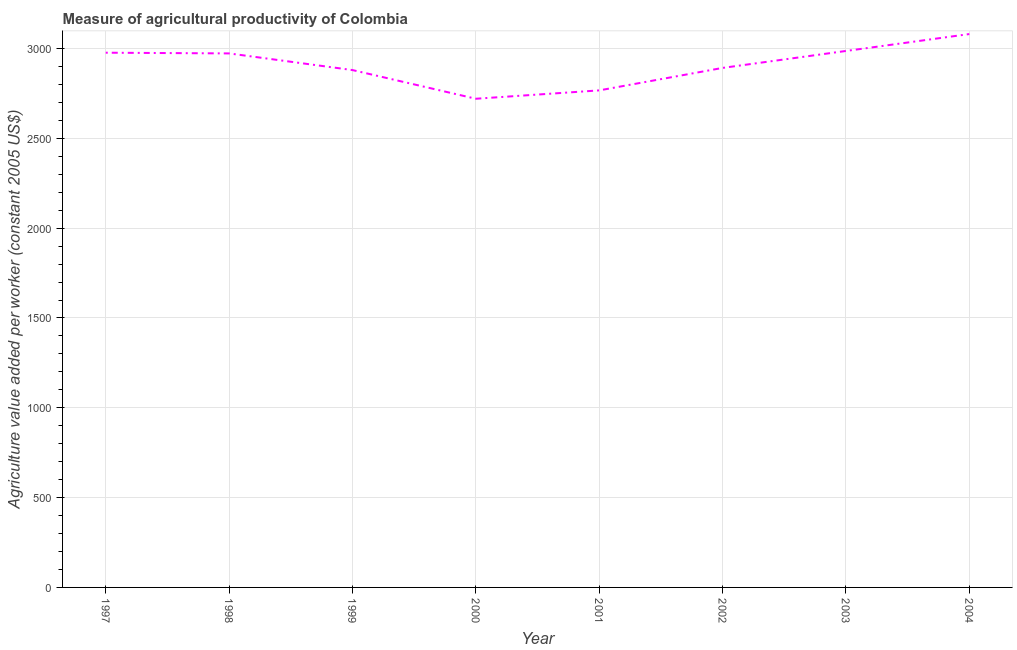What is the agriculture value added per worker in 2002?
Make the answer very short. 2892.19. Across all years, what is the maximum agriculture value added per worker?
Provide a short and direct response. 3080.64. Across all years, what is the minimum agriculture value added per worker?
Your response must be concise. 2720.53. What is the sum of the agriculture value added per worker?
Your answer should be very brief. 2.33e+04. What is the difference between the agriculture value added per worker in 1999 and 2004?
Your answer should be very brief. -200.45. What is the average agriculture value added per worker per year?
Make the answer very short. 2909.61. What is the median agriculture value added per worker?
Ensure brevity in your answer.  2932.52. In how many years, is the agriculture value added per worker greater than 600 US$?
Offer a terse response. 8. What is the ratio of the agriculture value added per worker in 2000 to that in 2004?
Provide a succinct answer. 0.88. Is the agriculture value added per worker in 2002 less than that in 2004?
Keep it short and to the point. Yes. Is the difference between the agriculture value added per worker in 2002 and 2004 greater than the difference between any two years?
Your answer should be very brief. No. What is the difference between the highest and the second highest agriculture value added per worker?
Offer a terse response. 94.08. Is the sum of the agriculture value added per worker in 1999 and 2003 greater than the maximum agriculture value added per worker across all years?
Offer a very short reply. Yes. What is the difference between the highest and the lowest agriculture value added per worker?
Provide a succinct answer. 360.11. In how many years, is the agriculture value added per worker greater than the average agriculture value added per worker taken over all years?
Provide a succinct answer. 4. Does the agriculture value added per worker monotonically increase over the years?
Offer a terse response. No. How many lines are there?
Make the answer very short. 1. How many years are there in the graph?
Make the answer very short. 8. Are the values on the major ticks of Y-axis written in scientific E-notation?
Provide a short and direct response. No. Does the graph contain any zero values?
Ensure brevity in your answer.  No. Does the graph contain grids?
Keep it short and to the point. Yes. What is the title of the graph?
Make the answer very short. Measure of agricultural productivity of Colombia. What is the label or title of the Y-axis?
Offer a terse response. Agriculture value added per worker (constant 2005 US$). What is the Agriculture value added per worker (constant 2005 US$) of 1997?
Provide a succinct answer. 2976.84. What is the Agriculture value added per worker (constant 2005 US$) in 1998?
Your answer should be very brief. 2972.85. What is the Agriculture value added per worker (constant 2005 US$) of 1999?
Offer a very short reply. 2880.19. What is the Agriculture value added per worker (constant 2005 US$) of 2000?
Provide a succinct answer. 2720.53. What is the Agriculture value added per worker (constant 2005 US$) in 2001?
Make the answer very short. 2767.07. What is the Agriculture value added per worker (constant 2005 US$) in 2002?
Offer a very short reply. 2892.19. What is the Agriculture value added per worker (constant 2005 US$) in 2003?
Offer a terse response. 2986.56. What is the Agriculture value added per worker (constant 2005 US$) in 2004?
Your response must be concise. 3080.64. What is the difference between the Agriculture value added per worker (constant 2005 US$) in 1997 and 1998?
Give a very brief answer. 3.99. What is the difference between the Agriculture value added per worker (constant 2005 US$) in 1997 and 1999?
Your answer should be very brief. 96.66. What is the difference between the Agriculture value added per worker (constant 2005 US$) in 1997 and 2000?
Keep it short and to the point. 256.32. What is the difference between the Agriculture value added per worker (constant 2005 US$) in 1997 and 2001?
Ensure brevity in your answer.  209.77. What is the difference between the Agriculture value added per worker (constant 2005 US$) in 1997 and 2002?
Make the answer very short. 84.65. What is the difference between the Agriculture value added per worker (constant 2005 US$) in 1997 and 2003?
Your answer should be very brief. -9.71. What is the difference between the Agriculture value added per worker (constant 2005 US$) in 1997 and 2004?
Offer a very short reply. -103.79. What is the difference between the Agriculture value added per worker (constant 2005 US$) in 1998 and 1999?
Offer a terse response. 92.67. What is the difference between the Agriculture value added per worker (constant 2005 US$) in 1998 and 2000?
Provide a short and direct response. 252.32. What is the difference between the Agriculture value added per worker (constant 2005 US$) in 1998 and 2001?
Keep it short and to the point. 205.78. What is the difference between the Agriculture value added per worker (constant 2005 US$) in 1998 and 2002?
Give a very brief answer. 80.66. What is the difference between the Agriculture value added per worker (constant 2005 US$) in 1998 and 2003?
Offer a very short reply. -13.71. What is the difference between the Agriculture value added per worker (constant 2005 US$) in 1998 and 2004?
Your answer should be very brief. -107.79. What is the difference between the Agriculture value added per worker (constant 2005 US$) in 1999 and 2000?
Your answer should be very brief. 159.66. What is the difference between the Agriculture value added per worker (constant 2005 US$) in 1999 and 2001?
Your answer should be very brief. 113.11. What is the difference between the Agriculture value added per worker (constant 2005 US$) in 1999 and 2002?
Your answer should be compact. -12. What is the difference between the Agriculture value added per worker (constant 2005 US$) in 1999 and 2003?
Offer a terse response. -106.37. What is the difference between the Agriculture value added per worker (constant 2005 US$) in 1999 and 2004?
Keep it short and to the point. -200.45. What is the difference between the Agriculture value added per worker (constant 2005 US$) in 2000 and 2001?
Offer a very short reply. -46.55. What is the difference between the Agriculture value added per worker (constant 2005 US$) in 2000 and 2002?
Keep it short and to the point. -171.66. What is the difference between the Agriculture value added per worker (constant 2005 US$) in 2000 and 2003?
Your response must be concise. -266.03. What is the difference between the Agriculture value added per worker (constant 2005 US$) in 2000 and 2004?
Your answer should be very brief. -360.11. What is the difference between the Agriculture value added per worker (constant 2005 US$) in 2001 and 2002?
Make the answer very short. -125.12. What is the difference between the Agriculture value added per worker (constant 2005 US$) in 2001 and 2003?
Your response must be concise. -219.48. What is the difference between the Agriculture value added per worker (constant 2005 US$) in 2001 and 2004?
Provide a short and direct response. -313.56. What is the difference between the Agriculture value added per worker (constant 2005 US$) in 2002 and 2003?
Give a very brief answer. -94.37. What is the difference between the Agriculture value added per worker (constant 2005 US$) in 2002 and 2004?
Provide a succinct answer. -188.45. What is the difference between the Agriculture value added per worker (constant 2005 US$) in 2003 and 2004?
Make the answer very short. -94.08. What is the ratio of the Agriculture value added per worker (constant 2005 US$) in 1997 to that in 1999?
Your response must be concise. 1.03. What is the ratio of the Agriculture value added per worker (constant 2005 US$) in 1997 to that in 2000?
Your response must be concise. 1.09. What is the ratio of the Agriculture value added per worker (constant 2005 US$) in 1997 to that in 2001?
Ensure brevity in your answer.  1.08. What is the ratio of the Agriculture value added per worker (constant 2005 US$) in 1997 to that in 2003?
Your response must be concise. 1. What is the ratio of the Agriculture value added per worker (constant 2005 US$) in 1998 to that in 1999?
Give a very brief answer. 1.03. What is the ratio of the Agriculture value added per worker (constant 2005 US$) in 1998 to that in 2000?
Offer a terse response. 1.09. What is the ratio of the Agriculture value added per worker (constant 2005 US$) in 1998 to that in 2001?
Offer a very short reply. 1.07. What is the ratio of the Agriculture value added per worker (constant 2005 US$) in 1998 to that in 2002?
Offer a terse response. 1.03. What is the ratio of the Agriculture value added per worker (constant 2005 US$) in 1999 to that in 2000?
Provide a succinct answer. 1.06. What is the ratio of the Agriculture value added per worker (constant 2005 US$) in 1999 to that in 2001?
Keep it short and to the point. 1.04. What is the ratio of the Agriculture value added per worker (constant 2005 US$) in 1999 to that in 2002?
Give a very brief answer. 1. What is the ratio of the Agriculture value added per worker (constant 2005 US$) in 1999 to that in 2004?
Provide a short and direct response. 0.94. What is the ratio of the Agriculture value added per worker (constant 2005 US$) in 2000 to that in 2002?
Make the answer very short. 0.94. What is the ratio of the Agriculture value added per worker (constant 2005 US$) in 2000 to that in 2003?
Offer a terse response. 0.91. What is the ratio of the Agriculture value added per worker (constant 2005 US$) in 2000 to that in 2004?
Keep it short and to the point. 0.88. What is the ratio of the Agriculture value added per worker (constant 2005 US$) in 2001 to that in 2002?
Your answer should be compact. 0.96. What is the ratio of the Agriculture value added per worker (constant 2005 US$) in 2001 to that in 2003?
Your answer should be very brief. 0.93. What is the ratio of the Agriculture value added per worker (constant 2005 US$) in 2001 to that in 2004?
Provide a short and direct response. 0.9. What is the ratio of the Agriculture value added per worker (constant 2005 US$) in 2002 to that in 2003?
Your answer should be compact. 0.97. What is the ratio of the Agriculture value added per worker (constant 2005 US$) in 2002 to that in 2004?
Your answer should be compact. 0.94. 